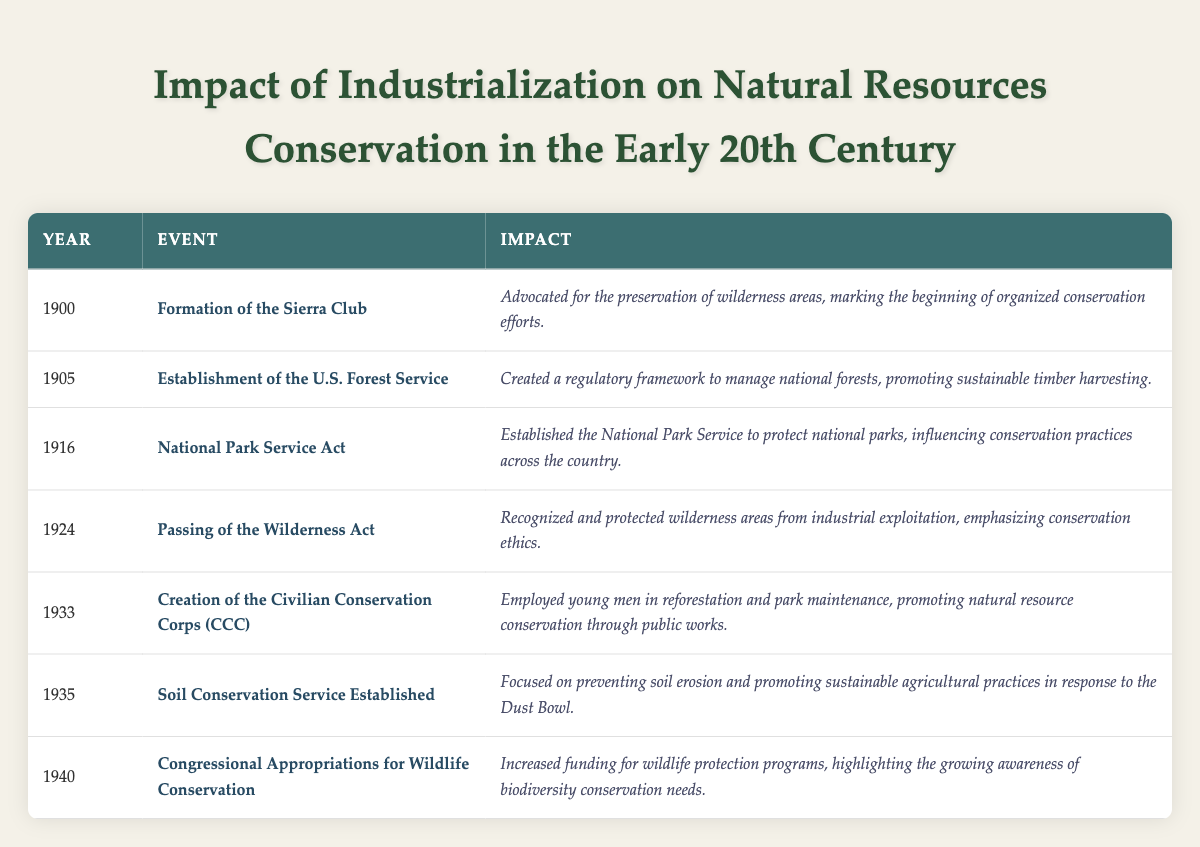What event marked the beginning of organized conservation efforts? The table indicates that the formation of the Sierra Club in 1900 was the first event listed, specifically advocating for wilderness area preservation.
Answer: Formation of the Sierra Club Which event established a regulatory framework for national forests? According to the table, the establishment of the U.S. Forest Service in 1905 created a framework to manage national forests.
Answer: Establishment of the U.S. Forest Service How many years passed between the creation of the Civilian Conservation Corps and the establishment of the Soil Conservation Service? The Civilian Conservation Corps was created in 1933 and the Soil Conservation Service was established in 1935. This results in a difference of 2 years (1935 - 1933).
Answer: 2 years Was the National Park Service Act passed before or after 1916? The date for the National Park Service Act is explicitly listed as 1916, so it cannot be before that year, making the answer false for before 1916.
Answer: No (false) What was the impact of the Wilderness Act passed in 1924? The table states that the impact of the Wilderness Act was to recognize and protect wilderness areas from industrial exploitation.
Answer: Recognized and protected wilderness areas Identify the first and last events listed in the table, and explain the significance. The first event in 1900 was the formation of the Sierra Club, which marked the start of organized conservation efforts. The last event in 1940 was Congressional Appropriations for Wildlife Conservation, which reflected increased funding for wildlife protection programs. Both events underscore the evolving emphasis on conservation.
Answer: Formation of the Sierra Club and Congressional Appropriations for Wildlife Conservation What percentage of the events listed involved the establishment of conservation organizations or services? There are 7 events in total, and 4 describe the formation or establishment of organizations/services: Sierra Club, U.S. Forest Service, National Park Service, and Soil Conservation Service. The calculation is (4/7) * 100 = 57.14%, which can be rounded to 57%.
Answer: 57% Which year saw the creation of the Civilian Conservation Corps, and what was its primary role? The Civilian Conservation Corps was created in 1933, and its primary role, as mentioned in the table, was to employ young men in reforestation and park maintenance.
Answer: 1933, employed in reforestation and park maintenance How did the establishment of the Soil Conservation Service in 1935 address environmental issues? The table notes that the Soil Conservation Service focused on preventing soil erosion in response to the Dust Bowl, which was an important environmental issue at the time.
Answer: Preventing soil erosion due to the Dust Bowl What actions did the National Park Service Act of 1916 promote regarding national parks? According to the table, the National Park Service Act established the National Park Service to protect national parks, influencing conservation practices nationwide.
Answer: Protect national parks What was a common theme concerning the impacts of events from 1900 to 1940 listed in the table? By reviewing the impacts of each event in the table, it's clear that conservation and sustainable management of natural resources are prevalent themes across all events from the Sierra Club's formation to wildlife protection funding in 1940.
Answer: Conservation and sustainable management of natural resources 